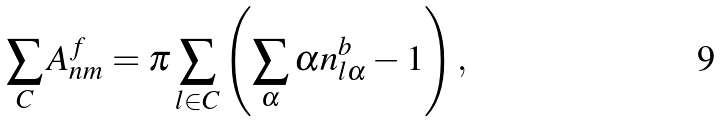Convert formula to latex. <formula><loc_0><loc_0><loc_500><loc_500>\, \sum _ { C } A _ { n m } ^ { f } = \pi \sum _ { l \in C } \left ( \sum _ { \alpha } \alpha n _ { l \alpha } ^ { b } - 1 \right ) ,</formula> 